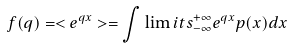Convert formula to latex. <formula><loc_0><loc_0><loc_500><loc_500>f ( q ) = < e ^ { q x } > = \int \lim i t s _ { - \infty } ^ { + \infty } e ^ { q x } p ( x ) d x</formula> 